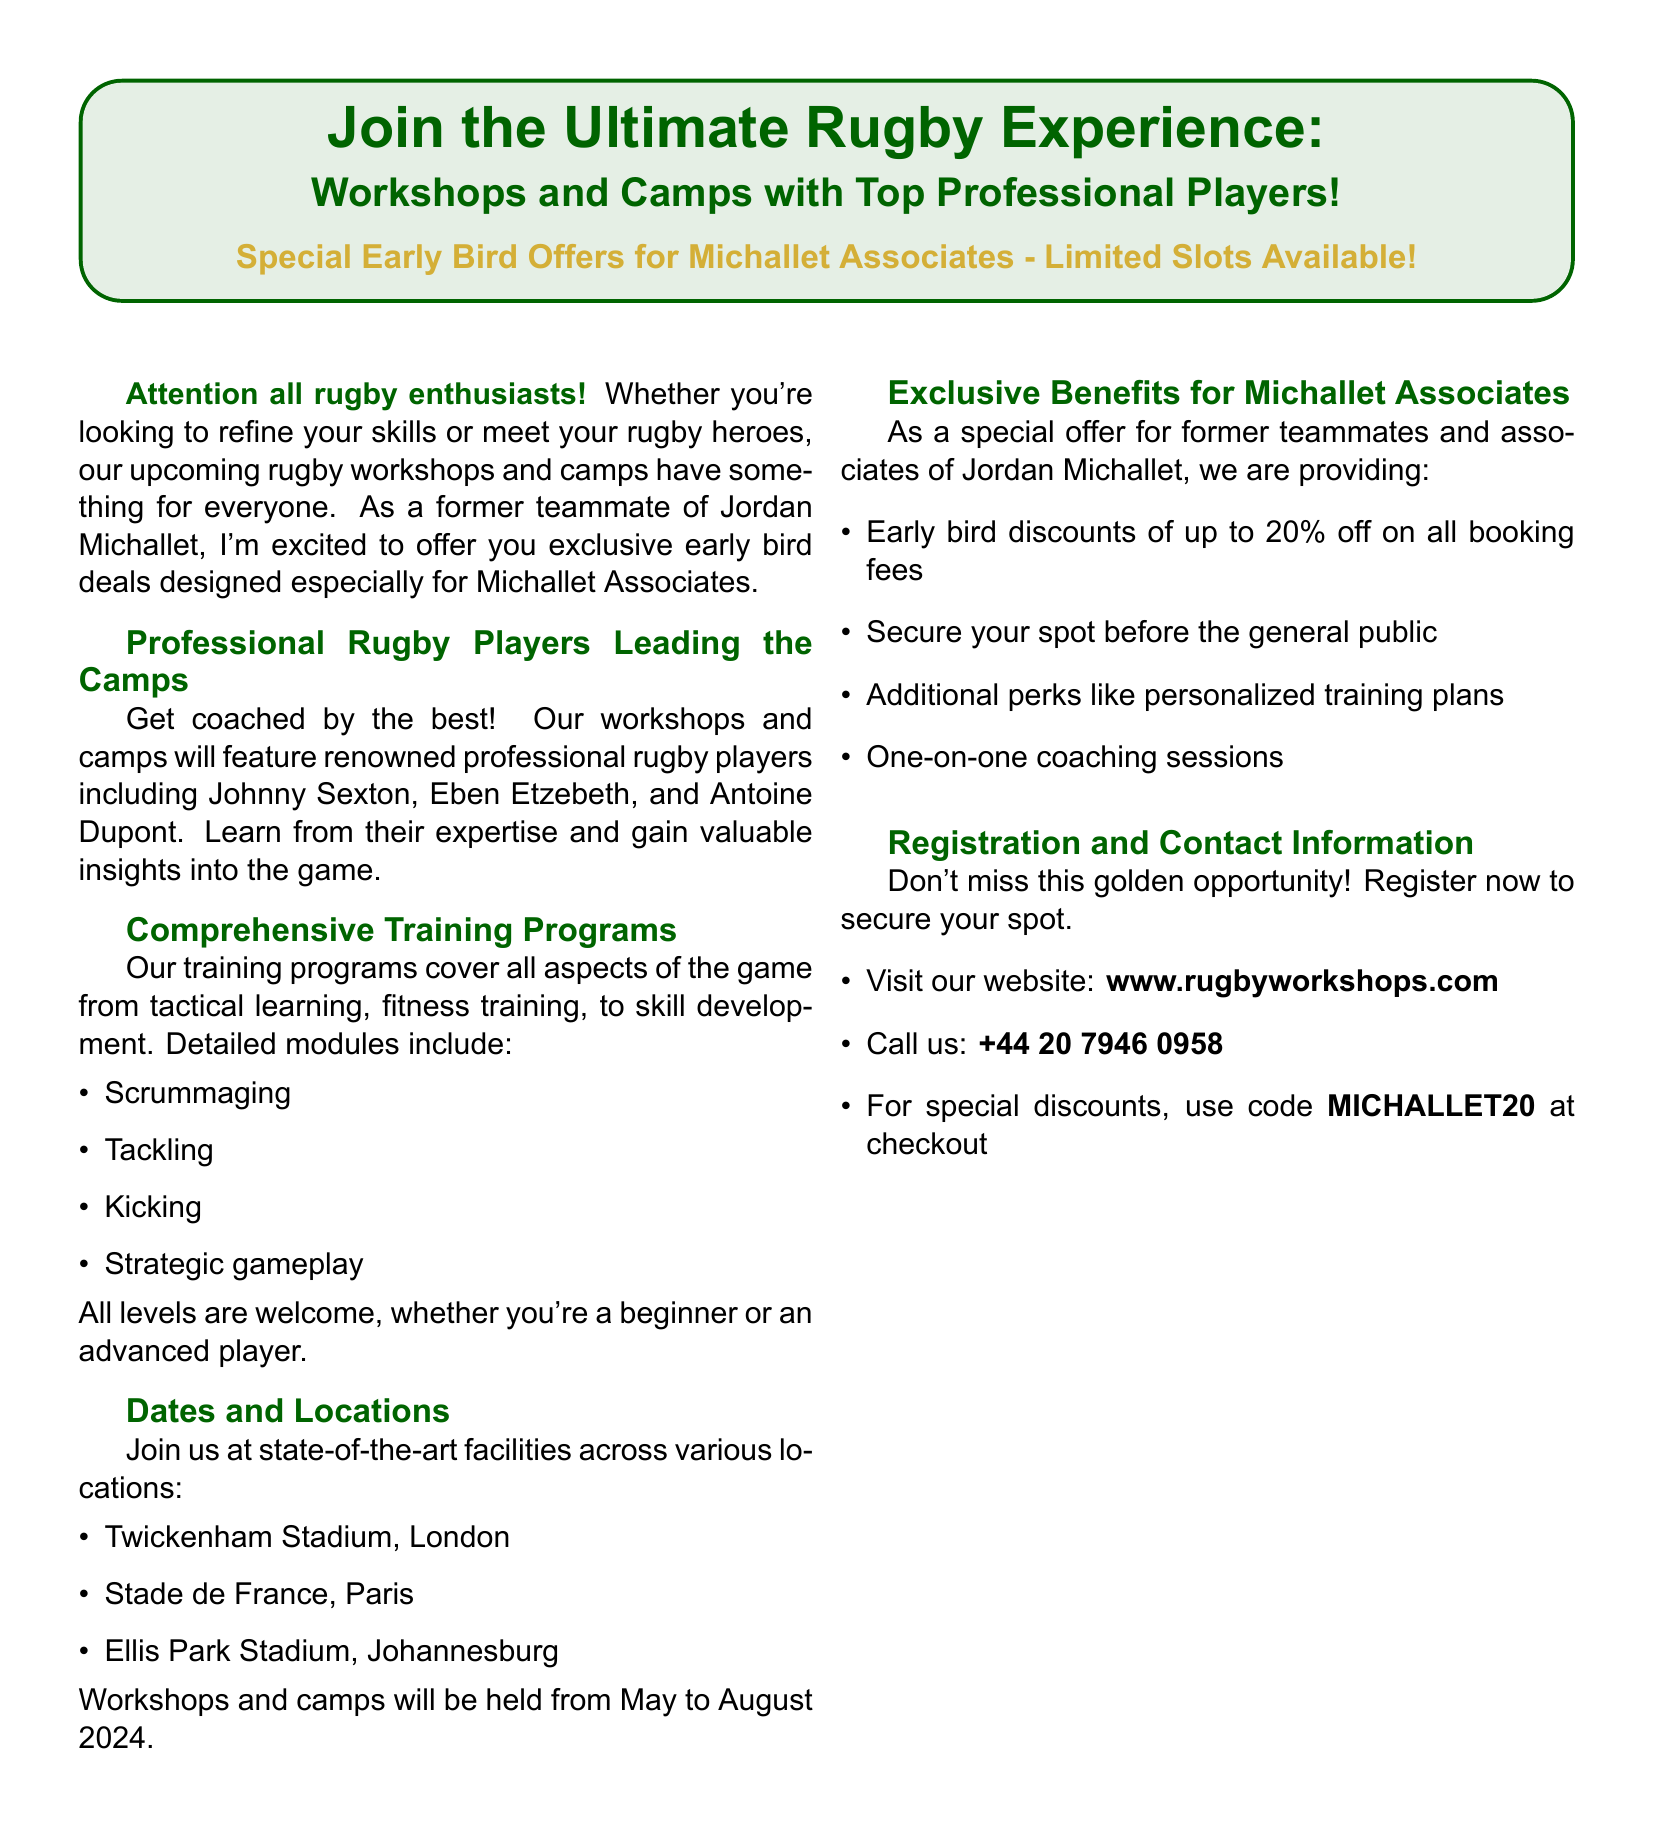What is the early bird discount percentage for Michallet Associates? The document specifies early bird discounts of up to 20% off on all booking fees for Michallet Associates.
Answer: 20% Which professional player is mentioned first in the lineup? The document lists Johnny Sexton as the first professional player leading the camps.
Answer: Johnny Sexton What are the two main types of training covered in the programs? The document mentions tactical learning and fitness training as two main aspects covered in the training programs.
Answer: Tactical learning and fitness training Where is one of the workshop locations? The document lists Twickenham Stadium in London as one of the workshop locations.
Answer: Twickenham Stadium, London What is the code for special discounts? The document provides the discount code as MICHALLET20 to use at checkout for special discounts.
Answer: MICHALLET20 What months will the workshops and camps be held? The document states that the workshops and camps will be held from May to August 2024.
Answer: May to August 2024 How many states of the art facilities are mentioned? The document provides a list of three locations, indicating that there are three state-of-the-art facilities mentioned.
Answer: Three What is a special benefit mentioned for Michallet Associates? One special benefit for Michallet Associates mentioned in the document is personalized training plans.
Answer: Personalized training plans 